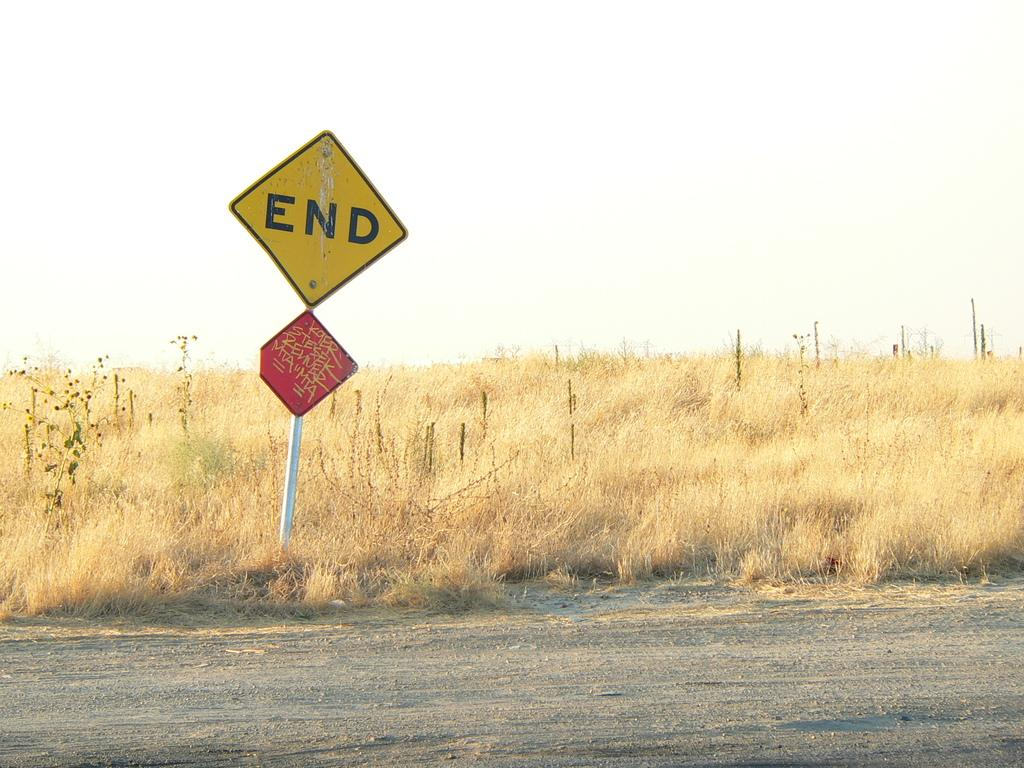<image>
Share a concise interpretation of the image provided. A field with an END road sign above a graffiti-tagged red diamond sign. 